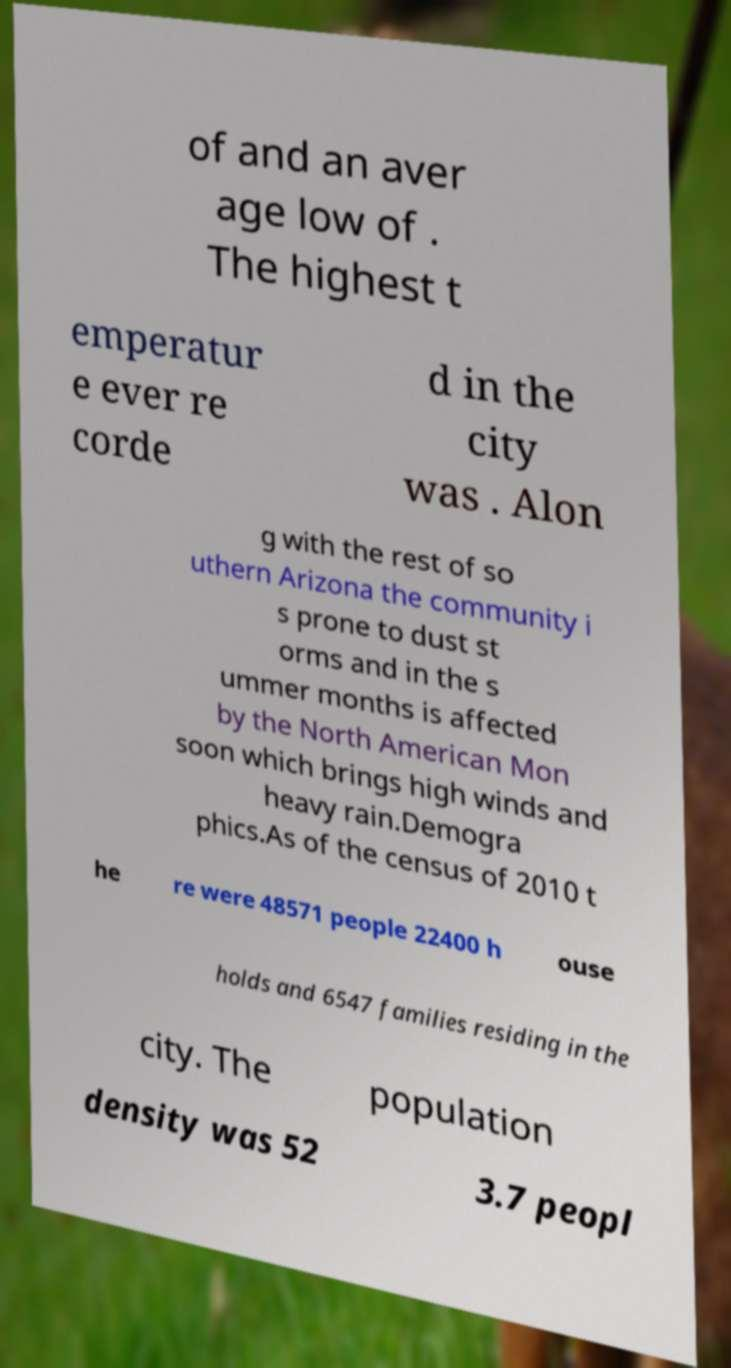There's text embedded in this image that I need extracted. Can you transcribe it verbatim? of and an aver age low of . The highest t emperatur e ever re corde d in the city was . Alon g with the rest of so uthern Arizona the community i s prone to dust st orms and in the s ummer months is affected by the North American Mon soon which brings high winds and heavy rain.Demogra phics.As of the census of 2010 t he re were 48571 people 22400 h ouse holds and 6547 families residing in the city. The population density was 52 3.7 peopl 